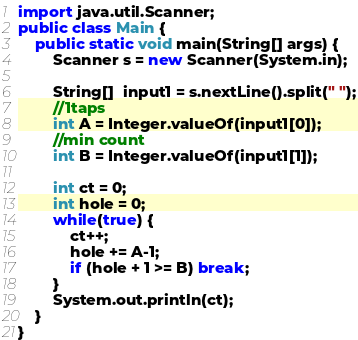<code> <loc_0><loc_0><loc_500><loc_500><_Java_>import java.util.Scanner;
public class Main {
    public static void main(String[] args) {
        Scanner s = new Scanner(System.in);

        String[]  input1 = s.nextLine().split(" ");
        //1taps
        int A = Integer.valueOf(input1[0]);
        //min count
        int B = Integer.valueOf(input1[1]);
        
        int ct = 0;
        int hole = 0;
        while(true) {
            ct++;
            hole += A-1;
            if (hole + 1 >= B) break;
        }
        System.out.println(ct);
    }
}</code> 